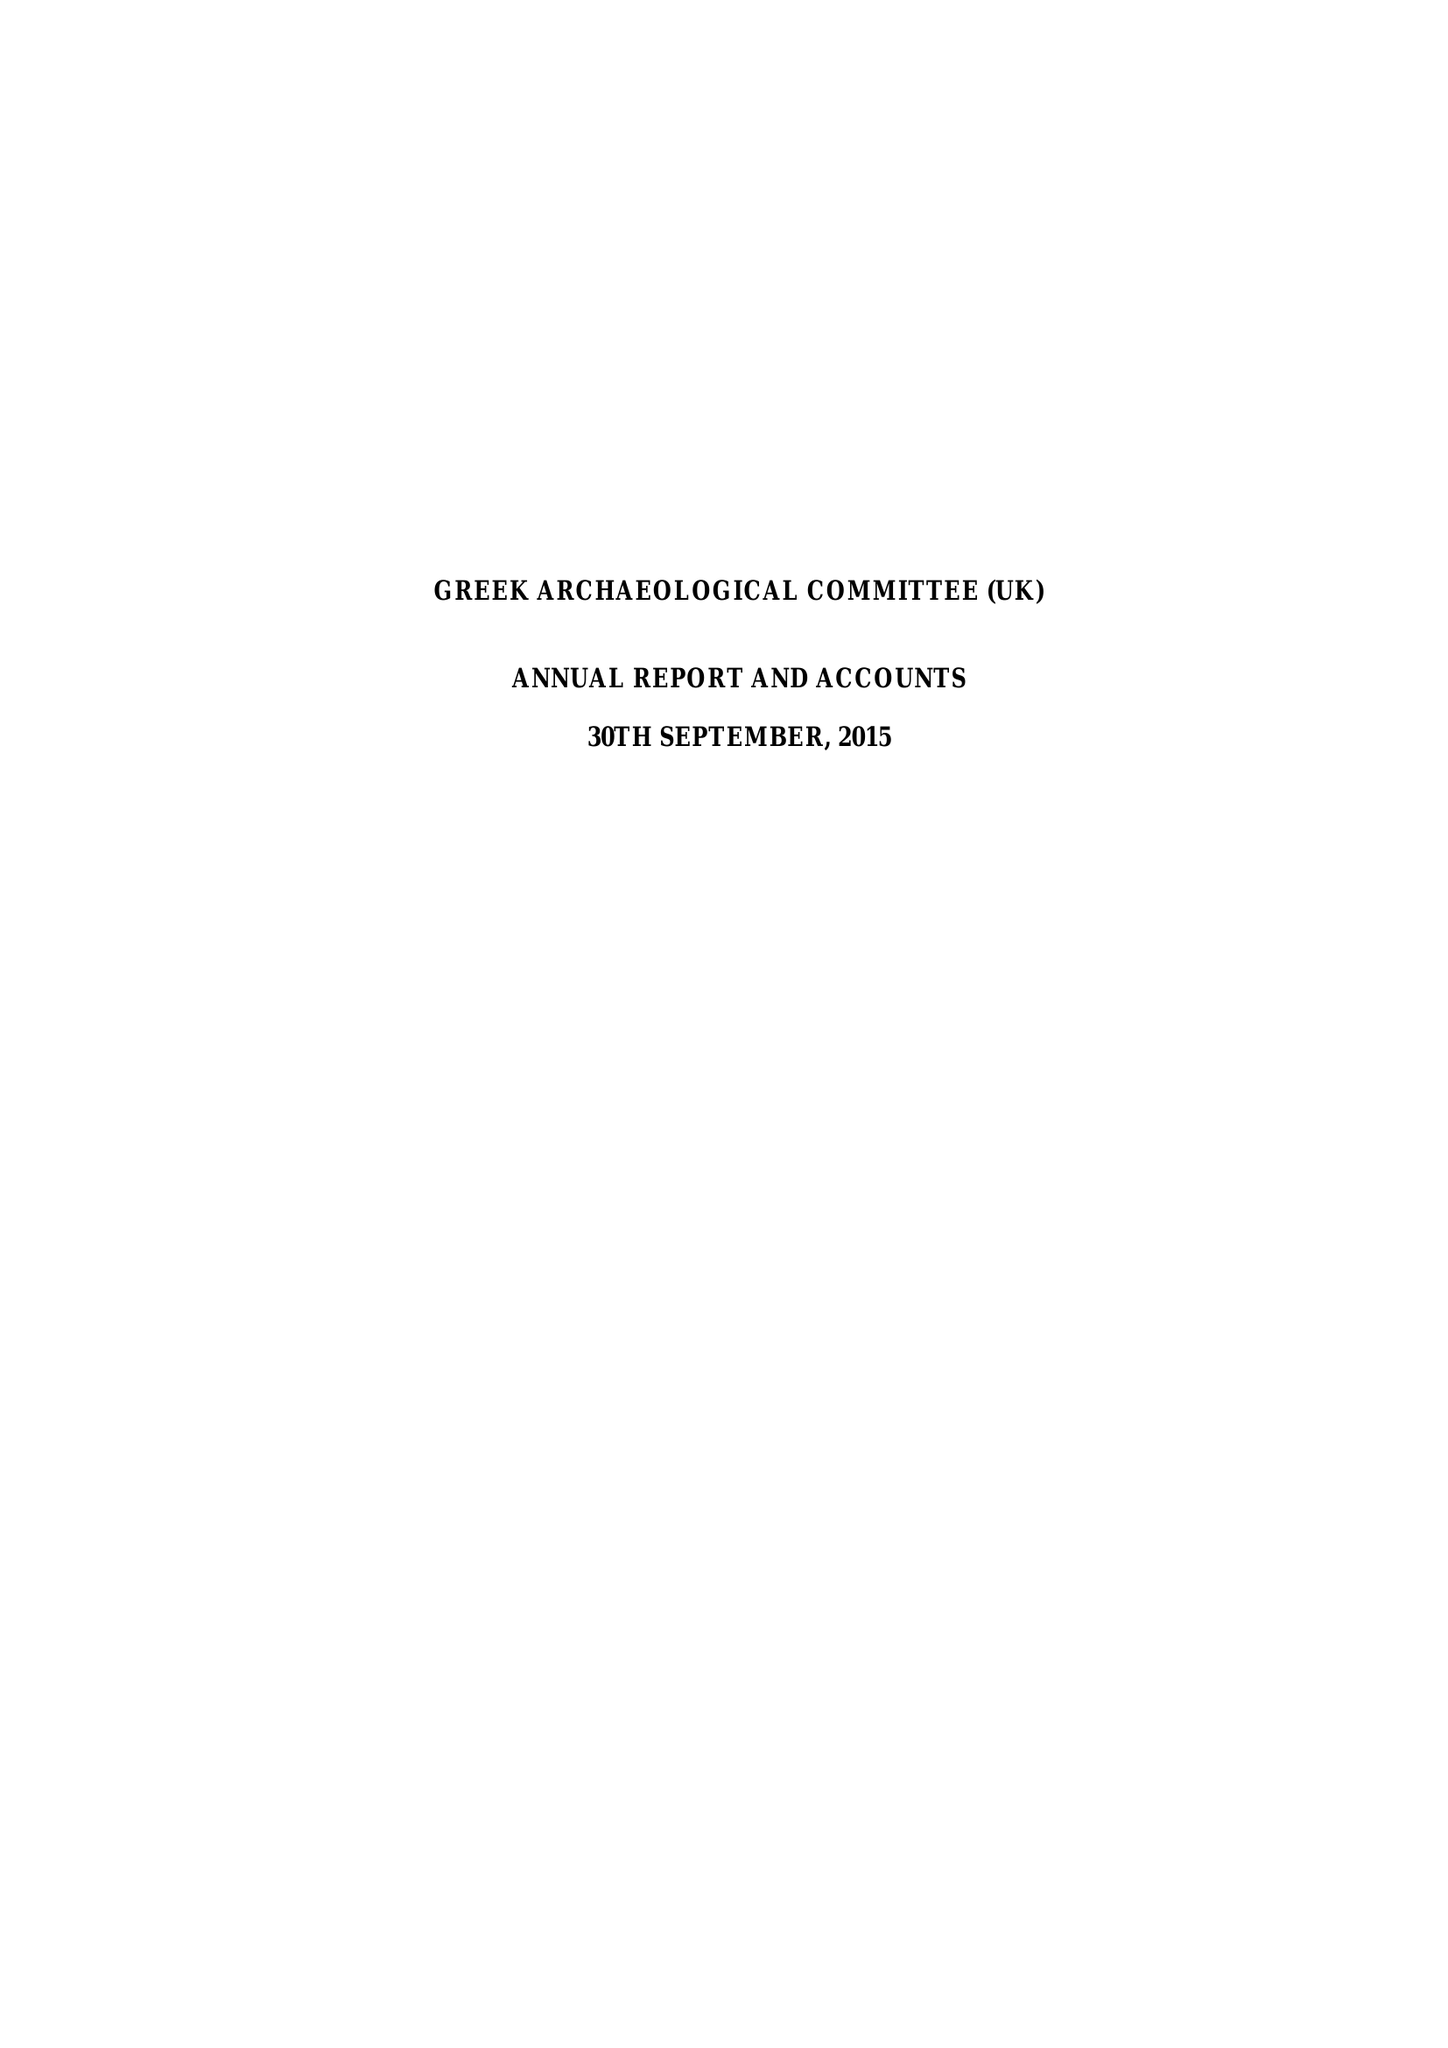What is the value for the address__postcode?
Answer the question using a single word or phrase. SW13 8QY 